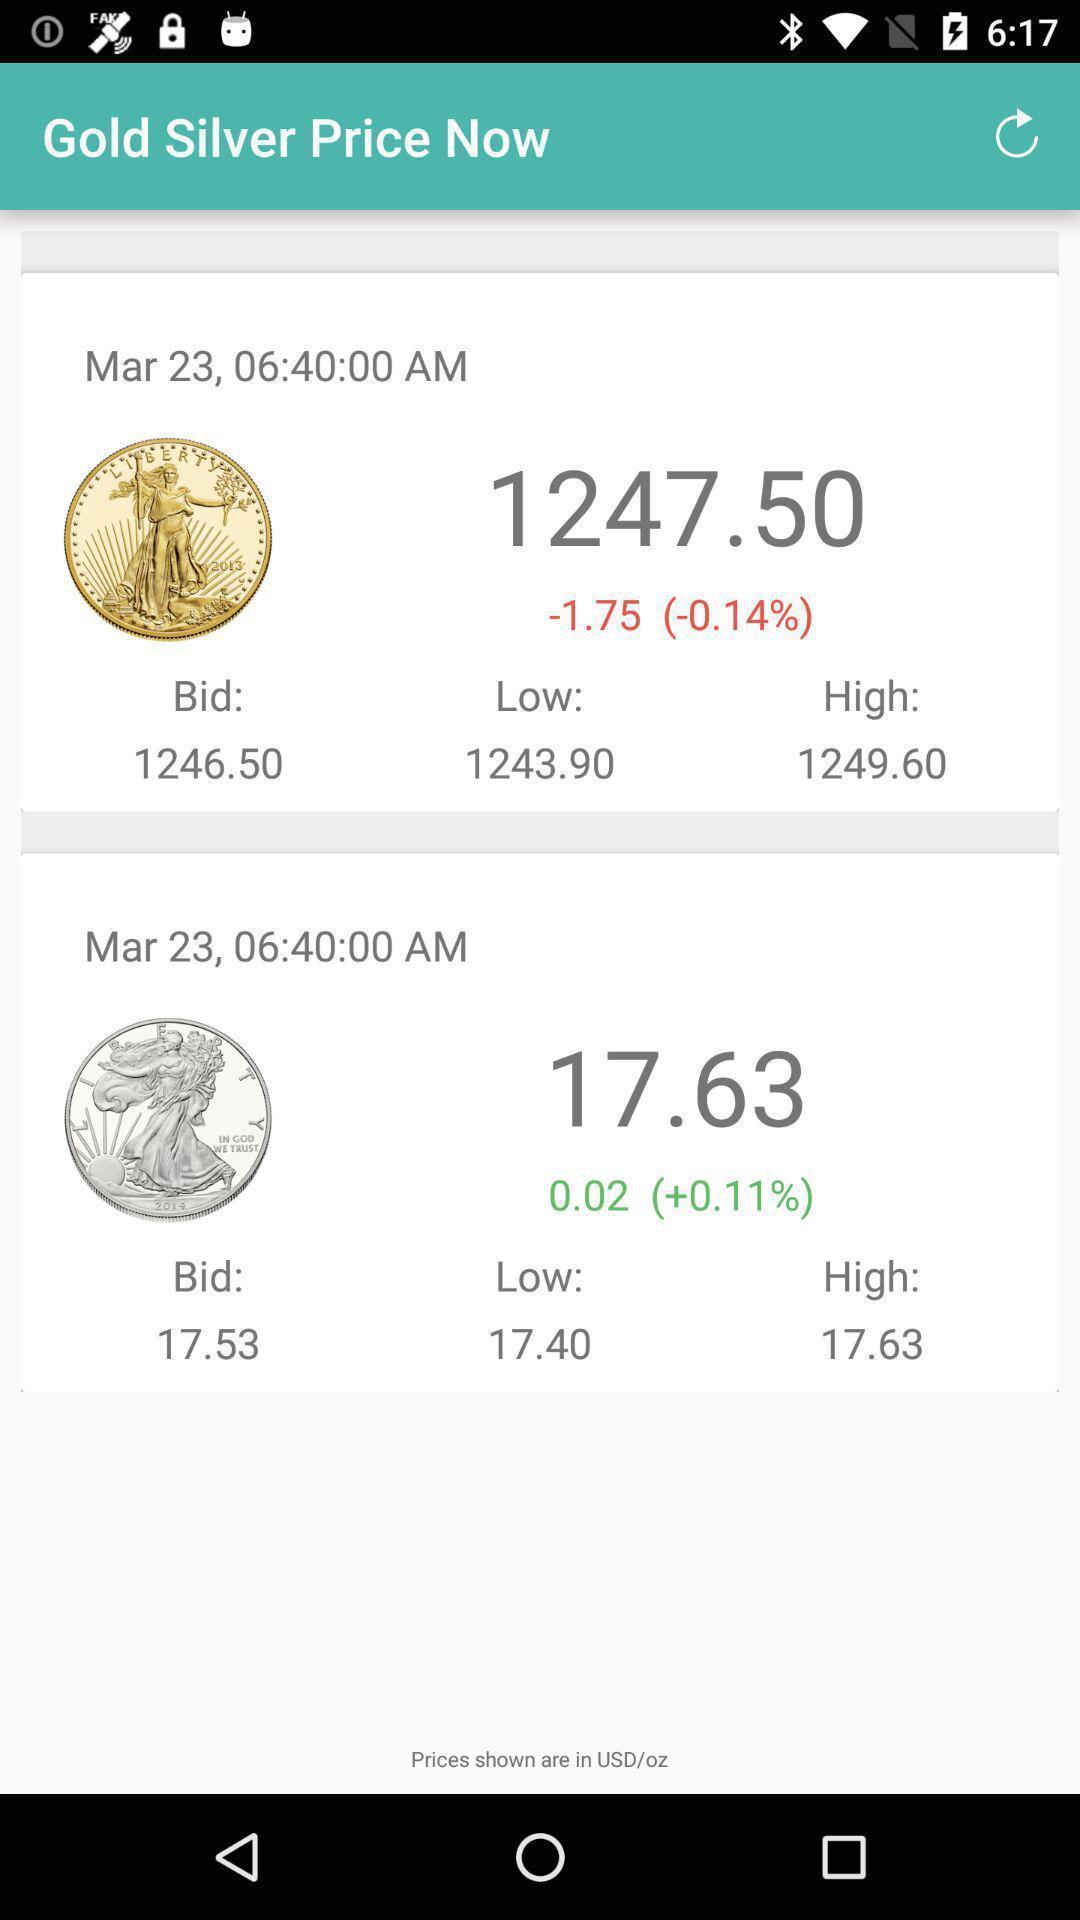Tell me what you see in this picture. Screen displaying gold and silver price page of an spp. 